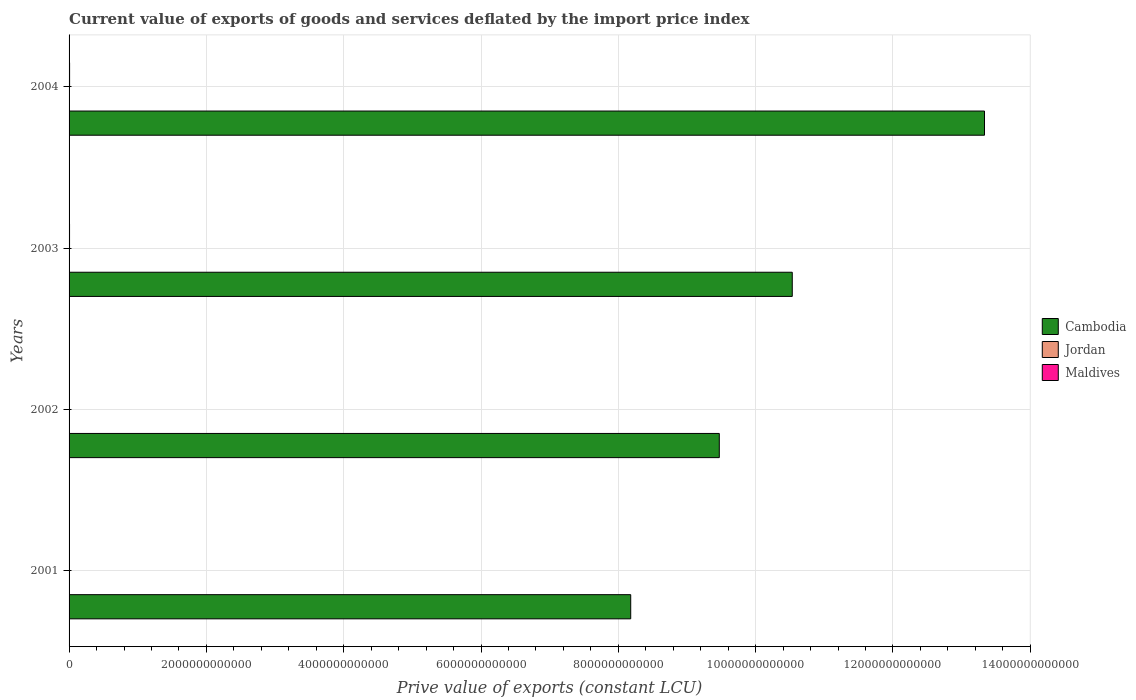Are the number of bars on each tick of the Y-axis equal?
Make the answer very short. Yes. What is the label of the 3rd group of bars from the top?
Make the answer very short. 2002. In how many cases, is the number of bars for a given year not equal to the number of legend labels?
Give a very brief answer. 0. What is the prive value of exports in Cambodia in 2001?
Your response must be concise. 8.18e+12. Across all years, what is the maximum prive value of exports in Cambodia?
Keep it short and to the point. 1.33e+13. Across all years, what is the minimum prive value of exports in Cambodia?
Provide a short and direct response. 8.18e+12. In which year was the prive value of exports in Cambodia maximum?
Offer a very short reply. 2004. In which year was the prive value of exports in Maldives minimum?
Your answer should be compact. 2001. What is the total prive value of exports in Maldives in the graph?
Ensure brevity in your answer.  2.63e+1. What is the difference between the prive value of exports in Cambodia in 2001 and that in 2003?
Give a very brief answer. -2.35e+12. What is the difference between the prive value of exports in Jordan in 2001 and the prive value of exports in Maldives in 2003?
Offer a very short reply. -4.73e+09. What is the average prive value of exports in Maldives per year?
Give a very brief answer. 6.57e+09. In the year 2001, what is the difference between the prive value of exports in Cambodia and prive value of exports in Maldives?
Your answer should be very brief. 8.17e+12. In how many years, is the prive value of exports in Cambodia greater than 1600000000000 LCU?
Offer a very short reply. 4. What is the ratio of the prive value of exports in Cambodia in 2002 to that in 2004?
Make the answer very short. 0.71. Is the difference between the prive value of exports in Cambodia in 2001 and 2004 greater than the difference between the prive value of exports in Maldives in 2001 and 2004?
Your response must be concise. No. What is the difference between the highest and the second highest prive value of exports in Jordan?
Ensure brevity in your answer.  1.98e+08. What is the difference between the highest and the lowest prive value of exports in Cambodia?
Offer a very short reply. 5.15e+12. Is the sum of the prive value of exports in Cambodia in 2001 and 2002 greater than the maximum prive value of exports in Jordan across all years?
Provide a short and direct response. Yes. What does the 3rd bar from the top in 2001 represents?
Make the answer very short. Cambodia. What does the 2nd bar from the bottom in 2004 represents?
Your answer should be compact. Jordan. How many bars are there?
Ensure brevity in your answer.  12. What is the difference between two consecutive major ticks on the X-axis?
Your response must be concise. 2.00e+12. Does the graph contain any zero values?
Make the answer very short. No. Does the graph contain grids?
Ensure brevity in your answer.  Yes. Where does the legend appear in the graph?
Provide a succinct answer. Center right. How many legend labels are there?
Ensure brevity in your answer.  3. What is the title of the graph?
Keep it short and to the point. Current value of exports of goods and services deflated by the import price index. What is the label or title of the X-axis?
Offer a terse response. Prive value of exports (constant LCU). What is the label or title of the Y-axis?
Your answer should be very brief. Years. What is the Prive value of exports (constant LCU) of Cambodia in 2001?
Your answer should be compact. 8.18e+12. What is the Prive value of exports (constant LCU) of Jordan in 2001?
Your response must be concise. 2.23e+09. What is the Prive value of exports (constant LCU) of Maldives in 2001?
Keep it short and to the point. 5.63e+09. What is the Prive value of exports (constant LCU) of Cambodia in 2002?
Your answer should be very brief. 9.47e+12. What is the Prive value of exports (constant LCU) in Jordan in 2002?
Offer a terse response. 2.62e+09. What is the Prive value of exports (constant LCU) of Maldives in 2002?
Provide a succinct answer. 6.05e+09. What is the Prive value of exports (constant LCU) in Cambodia in 2003?
Keep it short and to the point. 1.05e+13. What is the Prive value of exports (constant LCU) in Jordan in 2003?
Your answer should be compact. 2.56e+09. What is the Prive value of exports (constant LCU) of Maldives in 2003?
Provide a succinct answer. 6.97e+09. What is the Prive value of exports (constant LCU) of Cambodia in 2004?
Your answer should be very brief. 1.33e+13. What is the Prive value of exports (constant LCU) of Jordan in 2004?
Your answer should be very brief. 2.82e+09. What is the Prive value of exports (constant LCU) in Maldives in 2004?
Your response must be concise. 7.61e+09. Across all years, what is the maximum Prive value of exports (constant LCU) in Cambodia?
Provide a succinct answer. 1.33e+13. Across all years, what is the maximum Prive value of exports (constant LCU) of Jordan?
Make the answer very short. 2.82e+09. Across all years, what is the maximum Prive value of exports (constant LCU) in Maldives?
Your answer should be very brief. 7.61e+09. Across all years, what is the minimum Prive value of exports (constant LCU) in Cambodia?
Your response must be concise. 8.18e+12. Across all years, what is the minimum Prive value of exports (constant LCU) in Jordan?
Ensure brevity in your answer.  2.23e+09. Across all years, what is the minimum Prive value of exports (constant LCU) of Maldives?
Provide a succinct answer. 5.63e+09. What is the total Prive value of exports (constant LCU) in Cambodia in the graph?
Give a very brief answer. 4.15e+13. What is the total Prive value of exports (constant LCU) in Jordan in the graph?
Make the answer very short. 1.02e+1. What is the total Prive value of exports (constant LCU) of Maldives in the graph?
Your answer should be very brief. 2.63e+1. What is the difference between the Prive value of exports (constant LCU) of Cambodia in 2001 and that in 2002?
Provide a short and direct response. -1.29e+12. What is the difference between the Prive value of exports (constant LCU) of Jordan in 2001 and that in 2002?
Provide a succinct answer. -3.88e+08. What is the difference between the Prive value of exports (constant LCU) in Maldives in 2001 and that in 2002?
Your response must be concise. -4.14e+08. What is the difference between the Prive value of exports (constant LCU) in Cambodia in 2001 and that in 2003?
Offer a very short reply. -2.35e+12. What is the difference between the Prive value of exports (constant LCU) in Jordan in 2001 and that in 2003?
Provide a succinct answer. -3.28e+08. What is the difference between the Prive value of exports (constant LCU) in Maldives in 2001 and that in 2003?
Ensure brevity in your answer.  -1.33e+09. What is the difference between the Prive value of exports (constant LCU) of Cambodia in 2001 and that in 2004?
Your response must be concise. -5.15e+12. What is the difference between the Prive value of exports (constant LCU) of Jordan in 2001 and that in 2004?
Your response must be concise. -5.86e+08. What is the difference between the Prive value of exports (constant LCU) of Maldives in 2001 and that in 2004?
Provide a succinct answer. -1.98e+09. What is the difference between the Prive value of exports (constant LCU) of Cambodia in 2002 and that in 2003?
Your answer should be very brief. -1.06e+12. What is the difference between the Prive value of exports (constant LCU) of Jordan in 2002 and that in 2003?
Your answer should be very brief. 6.00e+07. What is the difference between the Prive value of exports (constant LCU) in Maldives in 2002 and that in 2003?
Your answer should be very brief. -9.20e+08. What is the difference between the Prive value of exports (constant LCU) in Cambodia in 2002 and that in 2004?
Provide a succinct answer. -3.86e+12. What is the difference between the Prive value of exports (constant LCU) of Jordan in 2002 and that in 2004?
Ensure brevity in your answer.  -1.98e+08. What is the difference between the Prive value of exports (constant LCU) of Maldives in 2002 and that in 2004?
Offer a very short reply. -1.57e+09. What is the difference between the Prive value of exports (constant LCU) in Cambodia in 2003 and that in 2004?
Provide a short and direct response. -2.80e+12. What is the difference between the Prive value of exports (constant LCU) of Jordan in 2003 and that in 2004?
Give a very brief answer. -2.58e+08. What is the difference between the Prive value of exports (constant LCU) of Maldives in 2003 and that in 2004?
Offer a very short reply. -6.47e+08. What is the difference between the Prive value of exports (constant LCU) in Cambodia in 2001 and the Prive value of exports (constant LCU) in Jordan in 2002?
Keep it short and to the point. 8.18e+12. What is the difference between the Prive value of exports (constant LCU) of Cambodia in 2001 and the Prive value of exports (constant LCU) of Maldives in 2002?
Offer a very short reply. 8.17e+12. What is the difference between the Prive value of exports (constant LCU) of Jordan in 2001 and the Prive value of exports (constant LCU) of Maldives in 2002?
Offer a terse response. -3.81e+09. What is the difference between the Prive value of exports (constant LCU) of Cambodia in 2001 and the Prive value of exports (constant LCU) of Jordan in 2003?
Make the answer very short. 8.18e+12. What is the difference between the Prive value of exports (constant LCU) of Cambodia in 2001 and the Prive value of exports (constant LCU) of Maldives in 2003?
Your answer should be very brief. 8.17e+12. What is the difference between the Prive value of exports (constant LCU) of Jordan in 2001 and the Prive value of exports (constant LCU) of Maldives in 2003?
Your answer should be compact. -4.73e+09. What is the difference between the Prive value of exports (constant LCU) in Cambodia in 2001 and the Prive value of exports (constant LCU) in Jordan in 2004?
Your response must be concise. 8.18e+12. What is the difference between the Prive value of exports (constant LCU) in Cambodia in 2001 and the Prive value of exports (constant LCU) in Maldives in 2004?
Make the answer very short. 8.17e+12. What is the difference between the Prive value of exports (constant LCU) in Jordan in 2001 and the Prive value of exports (constant LCU) in Maldives in 2004?
Provide a short and direct response. -5.38e+09. What is the difference between the Prive value of exports (constant LCU) in Cambodia in 2002 and the Prive value of exports (constant LCU) in Jordan in 2003?
Ensure brevity in your answer.  9.47e+12. What is the difference between the Prive value of exports (constant LCU) in Cambodia in 2002 and the Prive value of exports (constant LCU) in Maldives in 2003?
Offer a very short reply. 9.46e+12. What is the difference between the Prive value of exports (constant LCU) in Jordan in 2002 and the Prive value of exports (constant LCU) in Maldives in 2003?
Make the answer very short. -4.35e+09. What is the difference between the Prive value of exports (constant LCU) of Cambodia in 2002 and the Prive value of exports (constant LCU) of Jordan in 2004?
Keep it short and to the point. 9.47e+12. What is the difference between the Prive value of exports (constant LCU) of Cambodia in 2002 and the Prive value of exports (constant LCU) of Maldives in 2004?
Offer a terse response. 9.46e+12. What is the difference between the Prive value of exports (constant LCU) in Jordan in 2002 and the Prive value of exports (constant LCU) in Maldives in 2004?
Your response must be concise. -4.99e+09. What is the difference between the Prive value of exports (constant LCU) in Cambodia in 2003 and the Prive value of exports (constant LCU) in Jordan in 2004?
Ensure brevity in your answer.  1.05e+13. What is the difference between the Prive value of exports (constant LCU) in Cambodia in 2003 and the Prive value of exports (constant LCU) in Maldives in 2004?
Provide a succinct answer. 1.05e+13. What is the difference between the Prive value of exports (constant LCU) in Jordan in 2003 and the Prive value of exports (constant LCU) in Maldives in 2004?
Give a very brief answer. -5.05e+09. What is the average Prive value of exports (constant LCU) of Cambodia per year?
Your answer should be compact. 1.04e+13. What is the average Prive value of exports (constant LCU) of Jordan per year?
Your answer should be compact. 2.56e+09. What is the average Prive value of exports (constant LCU) in Maldives per year?
Provide a short and direct response. 6.57e+09. In the year 2001, what is the difference between the Prive value of exports (constant LCU) of Cambodia and Prive value of exports (constant LCU) of Jordan?
Your response must be concise. 8.18e+12. In the year 2001, what is the difference between the Prive value of exports (constant LCU) of Cambodia and Prive value of exports (constant LCU) of Maldives?
Your answer should be very brief. 8.17e+12. In the year 2001, what is the difference between the Prive value of exports (constant LCU) of Jordan and Prive value of exports (constant LCU) of Maldives?
Offer a terse response. -3.40e+09. In the year 2002, what is the difference between the Prive value of exports (constant LCU) in Cambodia and Prive value of exports (constant LCU) in Jordan?
Provide a succinct answer. 9.47e+12. In the year 2002, what is the difference between the Prive value of exports (constant LCU) of Cambodia and Prive value of exports (constant LCU) of Maldives?
Offer a very short reply. 9.46e+12. In the year 2002, what is the difference between the Prive value of exports (constant LCU) of Jordan and Prive value of exports (constant LCU) of Maldives?
Your answer should be very brief. -3.43e+09. In the year 2003, what is the difference between the Prive value of exports (constant LCU) in Cambodia and Prive value of exports (constant LCU) in Jordan?
Give a very brief answer. 1.05e+13. In the year 2003, what is the difference between the Prive value of exports (constant LCU) in Cambodia and Prive value of exports (constant LCU) in Maldives?
Give a very brief answer. 1.05e+13. In the year 2003, what is the difference between the Prive value of exports (constant LCU) in Jordan and Prive value of exports (constant LCU) in Maldives?
Offer a terse response. -4.41e+09. In the year 2004, what is the difference between the Prive value of exports (constant LCU) of Cambodia and Prive value of exports (constant LCU) of Jordan?
Your response must be concise. 1.33e+13. In the year 2004, what is the difference between the Prive value of exports (constant LCU) in Cambodia and Prive value of exports (constant LCU) in Maldives?
Your answer should be compact. 1.33e+13. In the year 2004, what is the difference between the Prive value of exports (constant LCU) of Jordan and Prive value of exports (constant LCU) of Maldives?
Your response must be concise. -4.80e+09. What is the ratio of the Prive value of exports (constant LCU) of Cambodia in 2001 to that in 2002?
Provide a short and direct response. 0.86. What is the ratio of the Prive value of exports (constant LCU) of Jordan in 2001 to that in 2002?
Offer a very short reply. 0.85. What is the ratio of the Prive value of exports (constant LCU) of Maldives in 2001 to that in 2002?
Your answer should be compact. 0.93. What is the ratio of the Prive value of exports (constant LCU) of Cambodia in 2001 to that in 2003?
Offer a terse response. 0.78. What is the ratio of the Prive value of exports (constant LCU) of Jordan in 2001 to that in 2003?
Keep it short and to the point. 0.87. What is the ratio of the Prive value of exports (constant LCU) of Maldives in 2001 to that in 2003?
Your response must be concise. 0.81. What is the ratio of the Prive value of exports (constant LCU) in Cambodia in 2001 to that in 2004?
Give a very brief answer. 0.61. What is the ratio of the Prive value of exports (constant LCU) in Jordan in 2001 to that in 2004?
Your answer should be very brief. 0.79. What is the ratio of the Prive value of exports (constant LCU) in Maldives in 2001 to that in 2004?
Provide a succinct answer. 0.74. What is the ratio of the Prive value of exports (constant LCU) of Cambodia in 2002 to that in 2003?
Give a very brief answer. 0.9. What is the ratio of the Prive value of exports (constant LCU) of Jordan in 2002 to that in 2003?
Your answer should be compact. 1.02. What is the ratio of the Prive value of exports (constant LCU) of Maldives in 2002 to that in 2003?
Your answer should be compact. 0.87. What is the ratio of the Prive value of exports (constant LCU) of Cambodia in 2002 to that in 2004?
Make the answer very short. 0.71. What is the ratio of the Prive value of exports (constant LCU) of Jordan in 2002 to that in 2004?
Offer a terse response. 0.93. What is the ratio of the Prive value of exports (constant LCU) in Maldives in 2002 to that in 2004?
Provide a succinct answer. 0.79. What is the ratio of the Prive value of exports (constant LCU) of Cambodia in 2003 to that in 2004?
Keep it short and to the point. 0.79. What is the ratio of the Prive value of exports (constant LCU) in Jordan in 2003 to that in 2004?
Your answer should be compact. 0.91. What is the ratio of the Prive value of exports (constant LCU) of Maldives in 2003 to that in 2004?
Provide a short and direct response. 0.92. What is the difference between the highest and the second highest Prive value of exports (constant LCU) in Cambodia?
Offer a very short reply. 2.80e+12. What is the difference between the highest and the second highest Prive value of exports (constant LCU) in Jordan?
Provide a short and direct response. 1.98e+08. What is the difference between the highest and the second highest Prive value of exports (constant LCU) in Maldives?
Make the answer very short. 6.47e+08. What is the difference between the highest and the lowest Prive value of exports (constant LCU) in Cambodia?
Ensure brevity in your answer.  5.15e+12. What is the difference between the highest and the lowest Prive value of exports (constant LCU) of Jordan?
Ensure brevity in your answer.  5.86e+08. What is the difference between the highest and the lowest Prive value of exports (constant LCU) of Maldives?
Offer a terse response. 1.98e+09. 